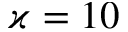Convert formula to latex. <formula><loc_0><loc_0><loc_500><loc_500>\varkappa = 1 0</formula> 